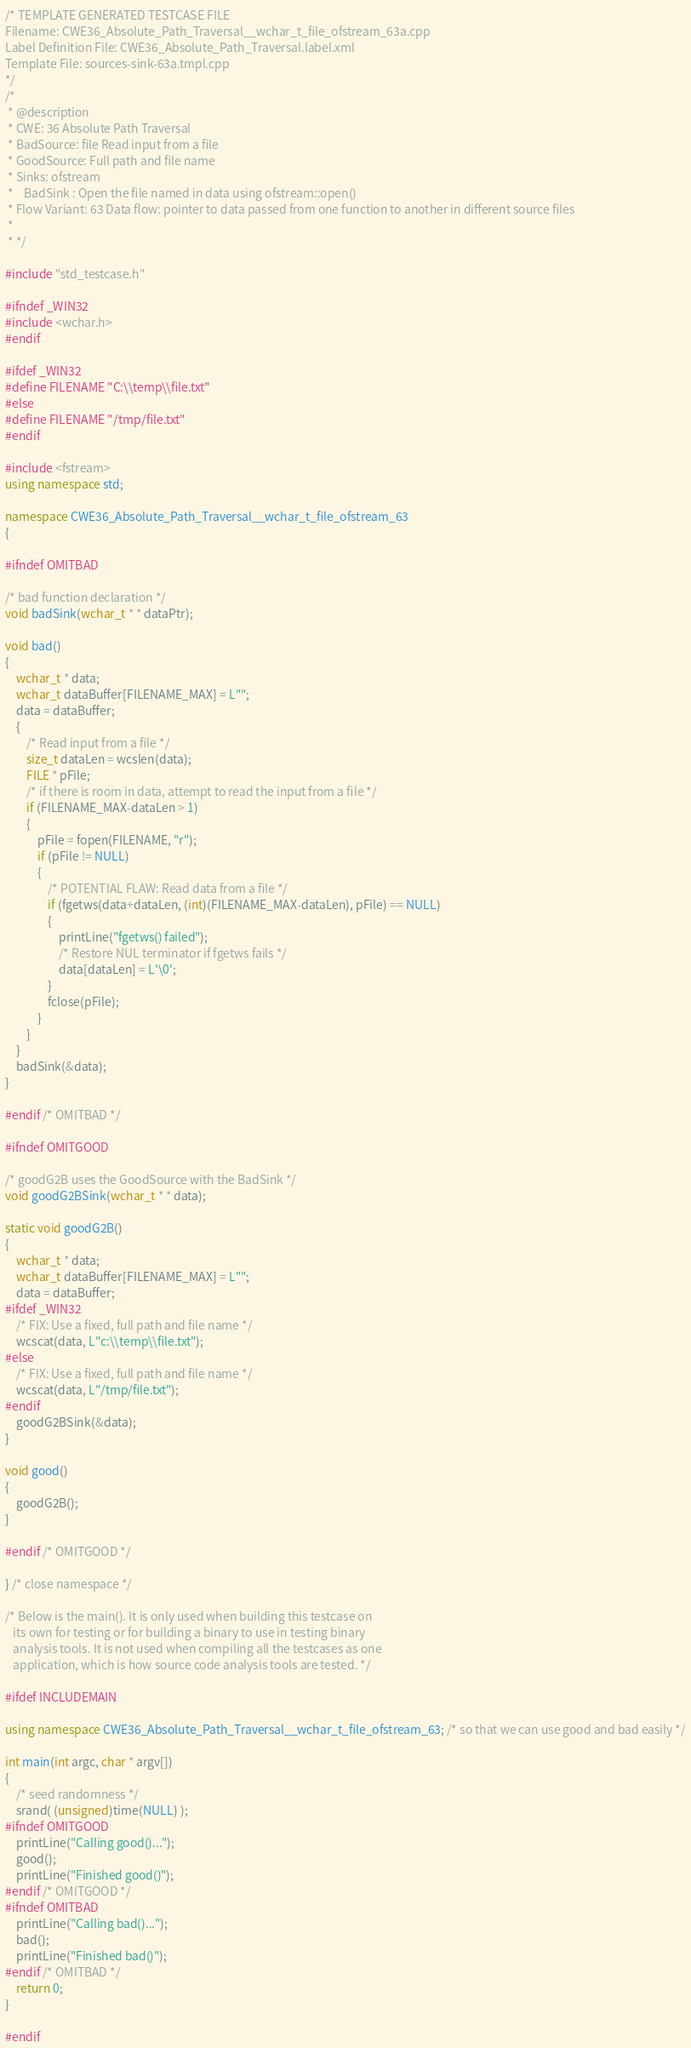<code> <loc_0><loc_0><loc_500><loc_500><_C++_>/* TEMPLATE GENERATED TESTCASE FILE
Filename: CWE36_Absolute_Path_Traversal__wchar_t_file_ofstream_63a.cpp
Label Definition File: CWE36_Absolute_Path_Traversal.label.xml
Template File: sources-sink-63a.tmpl.cpp
*/
/*
 * @description
 * CWE: 36 Absolute Path Traversal
 * BadSource: file Read input from a file
 * GoodSource: Full path and file name
 * Sinks: ofstream
 *    BadSink : Open the file named in data using ofstream::open()
 * Flow Variant: 63 Data flow: pointer to data passed from one function to another in different source files
 *
 * */

#include "std_testcase.h"

#ifndef _WIN32
#include <wchar.h>
#endif

#ifdef _WIN32
#define FILENAME "C:\\temp\\file.txt"
#else
#define FILENAME "/tmp/file.txt"
#endif

#include <fstream>
using namespace std;

namespace CWE36_Absolute_Path_Traversal__wchar_t_file_ofstream_63
{

#ifndef OMITBAD

/* bad function declaration */
void badSink(wchar_t * * dataPtr);

void bad()
{
    wchar_t * data;
    wchar_t dataBuffer[FILENAME_MAX] = L"";
    data = dataBuffer;
    {
        /* Read input from a file */
        size_t dataLen = wcslen(data);
        FILE * pFile;
        /* if there is room in data, attempt to read the input from a file */
        if (FILENAME_MAX-dataLen > 1)
        {
            pFile = fopen(FILENAME, "r");
            if (pFile != NULL)
            {
                /* POTENTIAL FLAW: Read data from a file */
                if (fgetws(data+dataLen, (int)(FILENAME_MAX-dataLen), pFile) == NULL)
                {
                    printLine("fgetws() failed");
                    /* Restore NUL terminator if fgetws fails */
                    data[dataLen] = L'\0';
                }
                fclose(pFile);
            }
        }
    }
    badSink(&data);
}

#endif /* OMITBAD */

#ifndef OMITGOOD

/* goodG2B uses the GoodSource with the BadSink */
void goodG2BSink(wchar_t * * data);

static void goodG2B()
{
    wchar_t * data;
    wchar_t dataBuffer[FILENAME_MAX] = L"";
    data = dataBuffer;
#ifdef _WIN32
    /* FIX: Use a fixed, full path and file name */
    wcscat(data, L"c:\\temp\\file.txt");
#else
    /* FIX: Use a fixed, full path and file name */
    wcscat(data, L"/tmp/file.txt");
#endif
    goodG2BSink(&data);
}

void good()
{
    goodG2B();
}

#endif /* OMITGOOD */

} /* close namespace */

/* Below is the main(). It is only used when building this testcase on
   its own for testing or for building a binary to use in testing binary
   analysis tools. It is not used when compiling all the testcases as one
   application, which is how source code analysis tools are tested. */

#ifdef INCLUDEMAIN

using namespace CWE36_Absolute_Path_Traversal__wchar_t_file_ofstream_63; /* so that we can use good and bad easily */

int main(int argc, char * argv[])
{
    /* seed randomness */
    srand( (unsigned)time(NULL) );
#ifndef OMITGOOD
    printLine("Calling good()...");
    good();
    printLine("Finished good()");
#endif /* OMITGOOD */
#ifndef OMITBAD
    printLine("Calling bad()...");
    bad();
    printLine("Finished bad()");
#endif /* OMITBAD */
    return 0;
}

#endif
</code> 